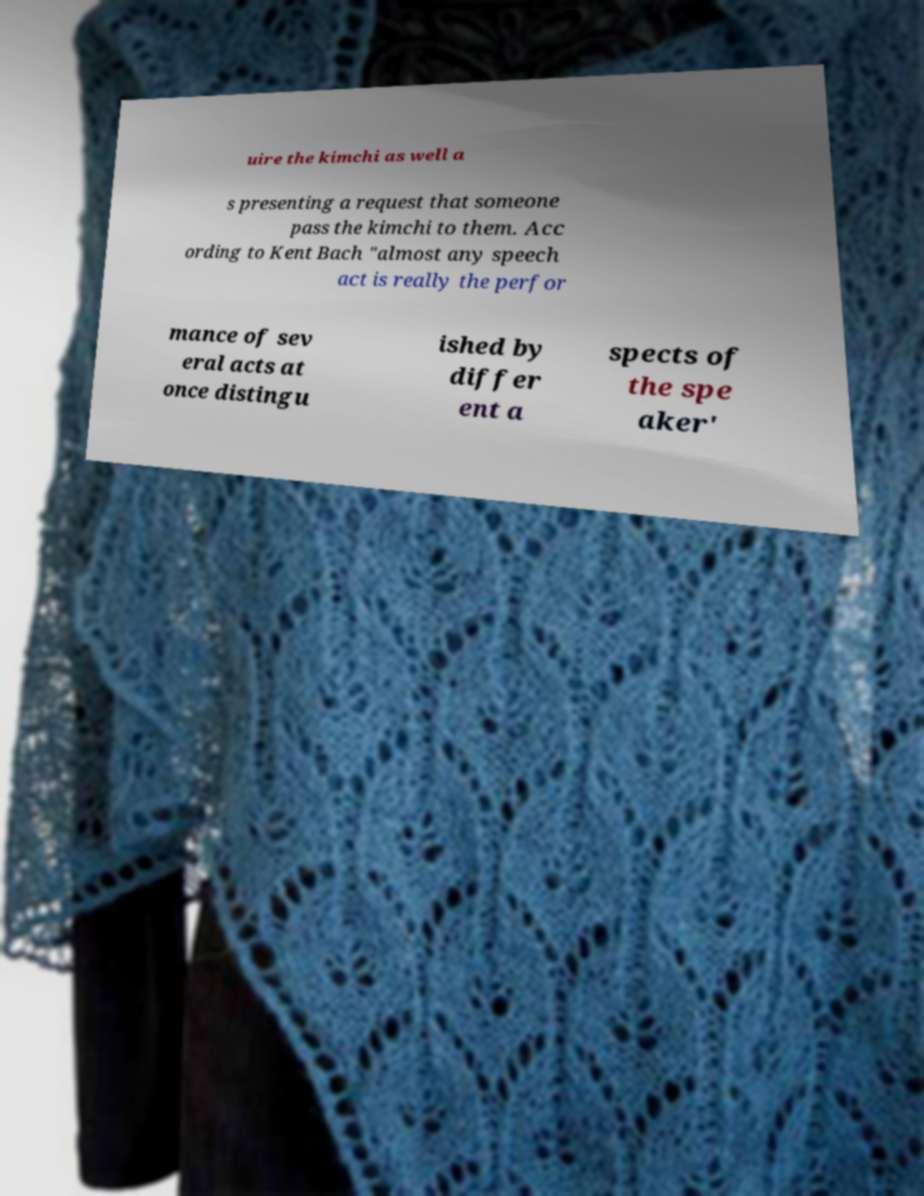I need the written content from this picture converted into text. Can you do that? uire the kimchi as well a s presenting a request that someone pass the kimchi to them. Acc ording to Kent Bach "almost any speech act is really the perfor mance of sev eral acts at once distingu ished by differ ent a spects of the spe aker' 